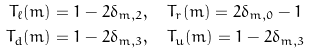Convert formula to latex. <formula><loc_0><loc_0><loc_500><loc_500>T _ { \ell } ( m ) & = 1 - 2 \delta _ { m , 2 } , \quad T _ { r } ( m ) = 2 \delta _ { m , 0 } - 1 \\ T _ { d } ( m ) & = 1 - 2 \delta _ { m , 3 } , \quad T _ { u } ( m ) = 1 - 2 \delta _ { m , 3 }</formula> 